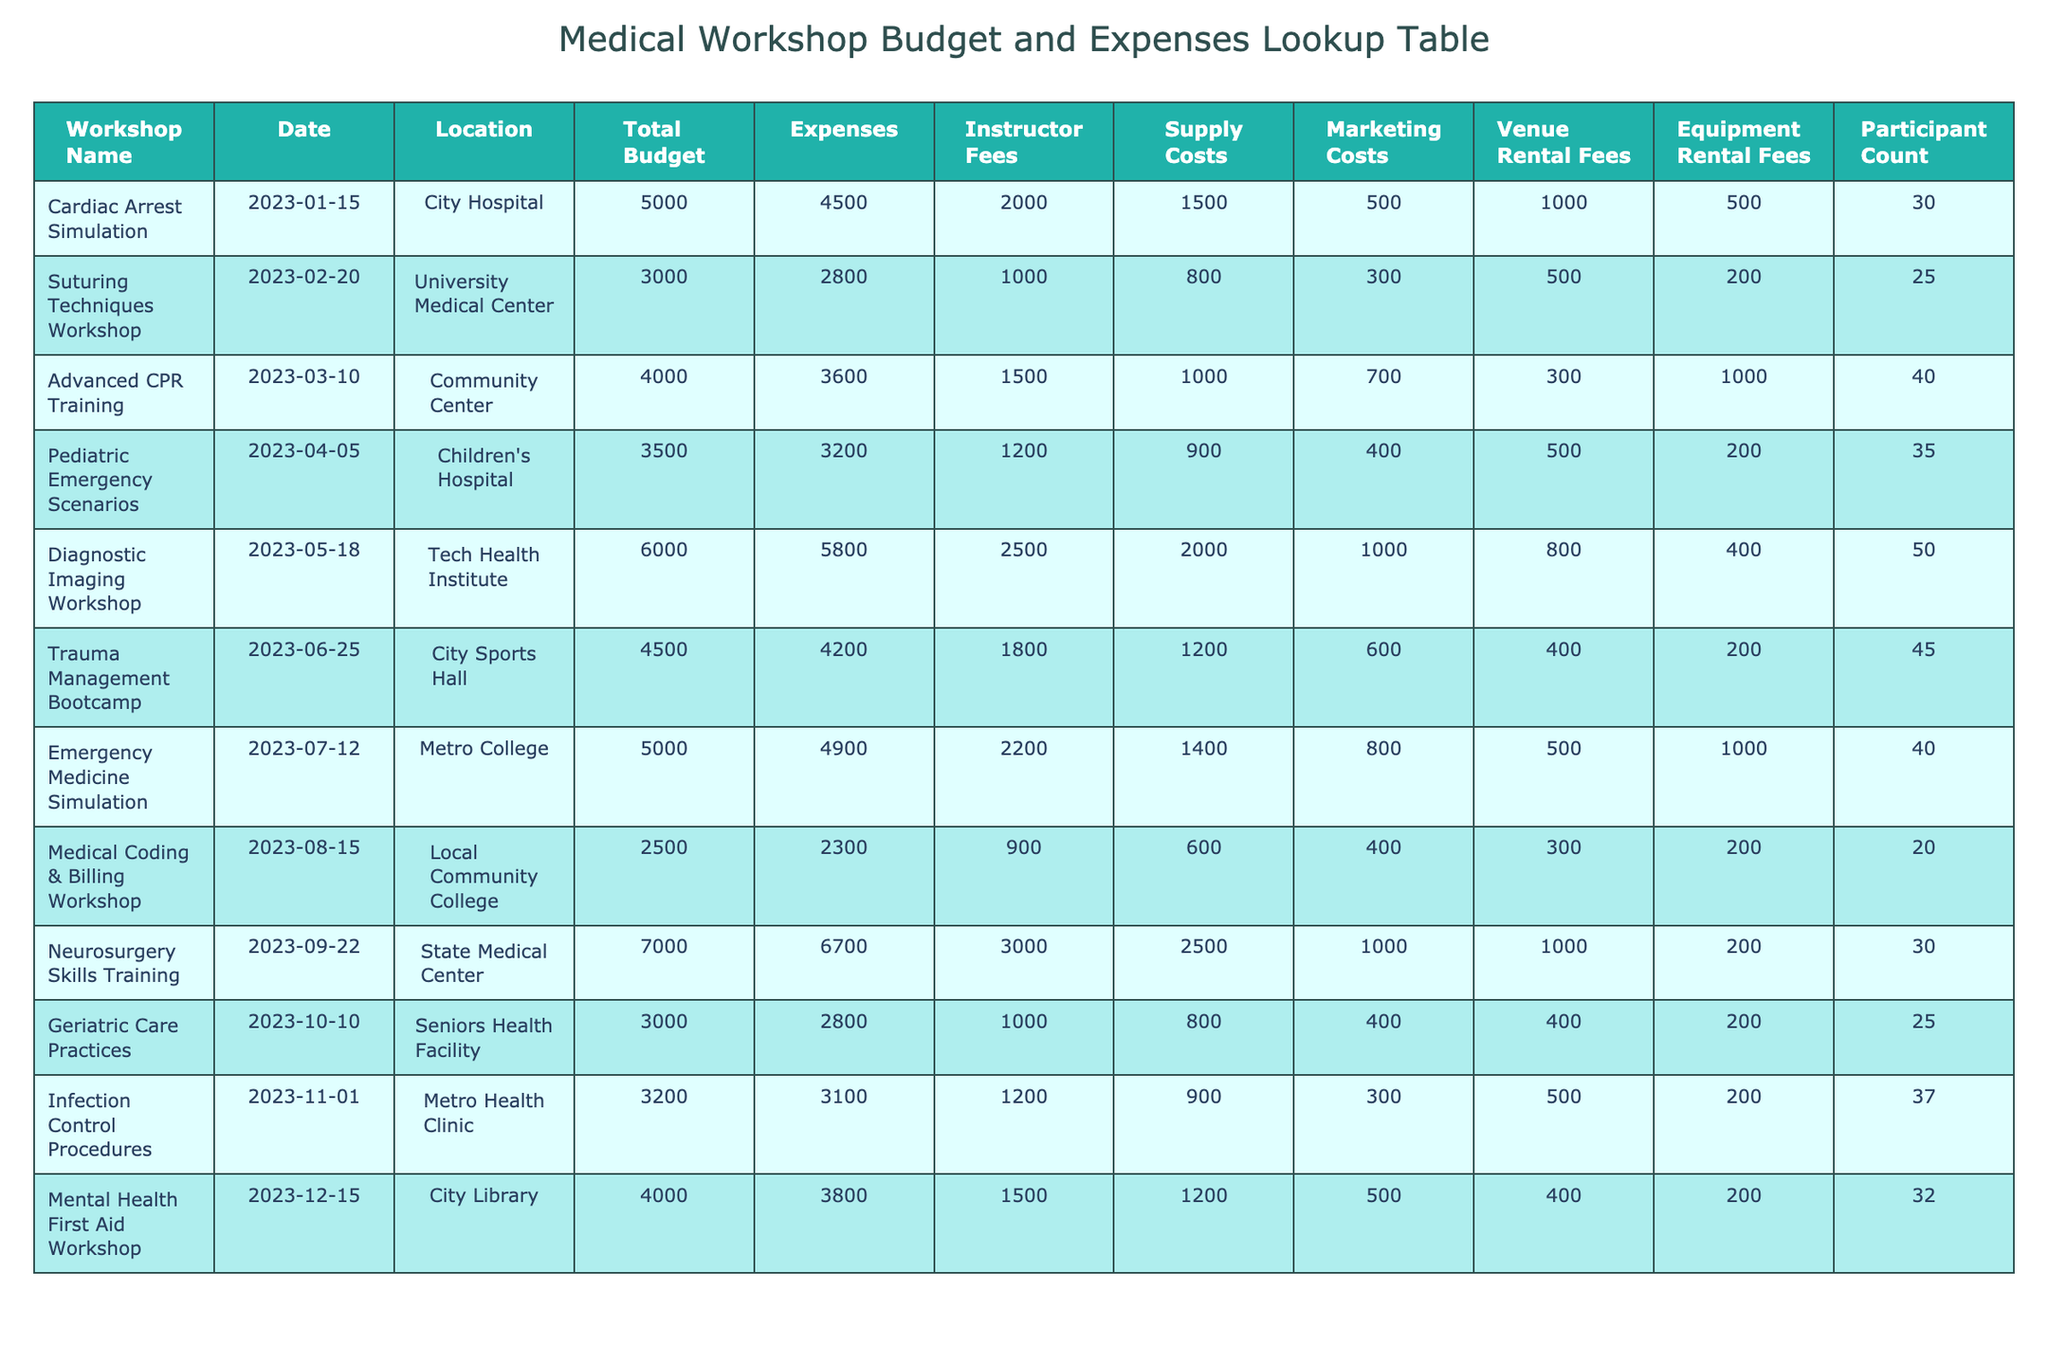What is the total budget for the "Neurosurgery Skills Training"? The table shows that the total budget for the workshop “Neurosurgery Skills Training” is listed under the Total Budget column. It is 7000.
Answer: 7000 Which workshop had the highest supply costs? By examining the Supply Costs column, we determine that “Diagnostic Imaging Workshop” has the highest supply costs at 2000.
Answer: 2000 What is the average participant count across all workshops? To find the average, add the participant counts: (30 + 25 + 40 + 35 + 50 + 45 + 40 + 20 + 30 + 25 + 37 + 32) = 392. There are 12 workshops, so the average is 392/12 = 32.67, which can be simplified to approximately 33.
Answer: 33 Did the "Emergency Medicine Simulation" stay within its budget? The expenses for "Emergency Medicine Simulation" are 4900, which is less than its budget of 5000. Thus, it did stay within budget.
Answer: Yes What is the total expense incurred for workshops held in the first half of the year (January to June)? Adding the expenses for the first half of the year: 4500 + 2800 + 3600 + 3200 + 5800 + 4200 = 24100.
Answer: 24100 Which workshop had the lowest marketing costs? By checking the Marketing Costs column, we can see that the “Suturing Techniques Workshop” has the lowest marketing costs at 300.
Answer: 300 How much was spent on instructor fees for all workshops combined? To find the total for instructor fees, we add: (2000 + 1000 + 1500 + 1200 + 2500 + 1800 + 2200 + 900 + 3000 + 1000 + 1200 + 1500) = 18600.
Answer: 18600 Is the "Pediatric Emergency Scenarios" workshop more expensive than the total budget stated? The expenses for "Pediatric Emergency Scenarios" are 3200, which is less than its total budget of 3500; hence, it is not more expensive.
Answer: No What percentage of the total budget was actually spent on the "Cardiac Arrest Simulation"? The expenses for the "Cardiac Arrest Simulation" are 4500, and the total budget is 5000. To find the percentage spent, calculate (4500 / 5000) * 100% = 90%.
Answer: 90% 